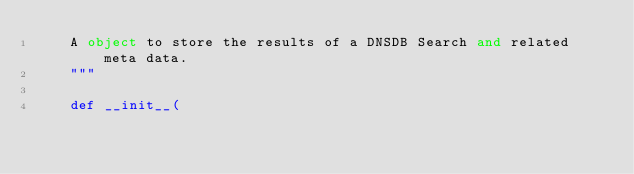<code> <loc_0><loc_0><loc_500><loc_500><_Python_>    A object to store the results of a DNSDB Search and related meta data.
    """

    def __init__(</code> 